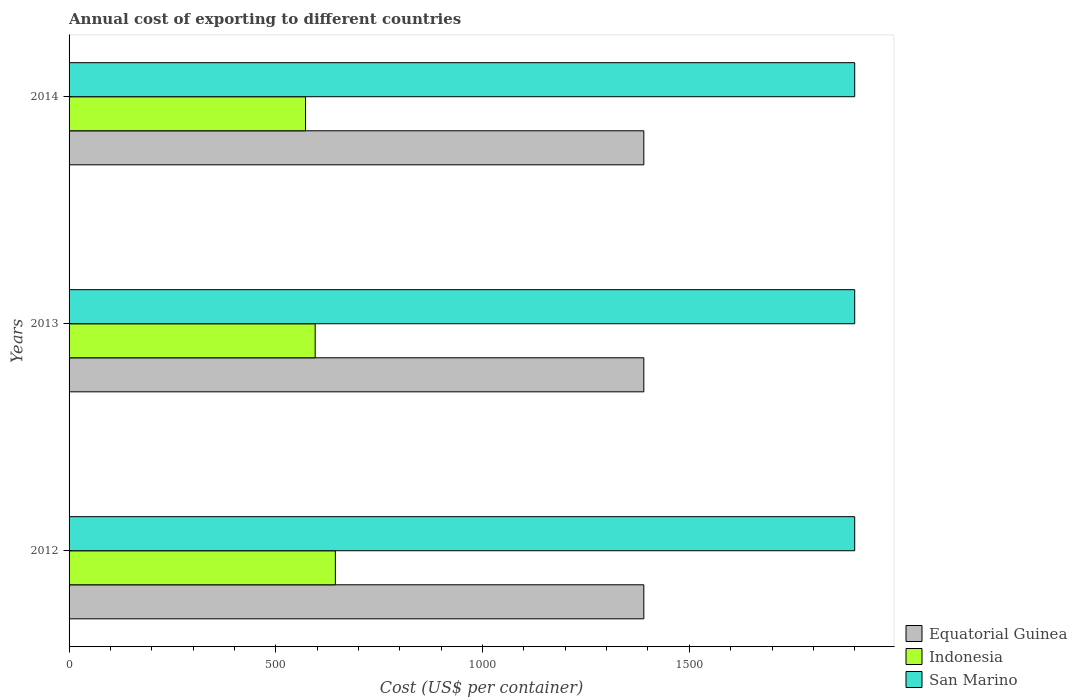What is the total annual cost of exporting in San Marino in 2013?
Your answer should be compact. 1900. Across all years, what is the maximum total annual cost of exporting in Indonesia?
Keep it short and to the point. 644. Across all years, what is the minimum total annual cost of exporting in Indonesia?
Provide a succinct answer. 571.8. In which year was the total annual cost of exporting in San Marino maximum?
Provide a short and direct response. 2012. What is the total total annual cost of exporting in Indonesia in the graph?
Keep it short and to the point. 1811. What is the difference between the total annual cost of exporting in Indonesia in 2012 and that in 2013?
Ensure brevity in your answer.  48.8. What is the difference between the total annual cost of exporting in Indonesia in 2014 and the total annual cost of exporting in San Marino in 2012?
Your response must be concise. -1328.2. What is the average total annual cost of exporting in Equatorial Guinea per year?
Your response must be concise. 1390. In the year 2012, what is the difference between the total annual cost of exporting in Equatorial Guinea and total annual cost of exporting in San Marino?
Provide a succinct answer. -510. In how many years, is the total annual cost of exporting in Indonesia greater than 1300 US$?
Your response must be concise. 0. What is the ratio of the total annual cost of exporting in San Marino in 2012 to that in 2013?
Provide a short and direct response. 1. What is the difference between the highest and the second highest total annual cost of exporting in Indonesia?
Keep it short and to the point. 48.8. What is the difference between the highest and the lowest total annual cost of exporting in San Marino?
Offer a very short reply. 0. In how many years, is the total annual cost of exporting in San Marino greater than the average total annual cost of exporting in San Marino taken over all years?
Offer a terse response. 0. Is the sum of the total annual cost of exporting in Indonesia in 2012 and 2014 greater than the maximum total annual cost of exporting in Equatorial Guinea across all years?
Offer a very short reply. No. What does the 3rd bar from the top in 2012 represents?
Keep it short and to the point. Equatorial Guinea. How many bars are there?
Your answer should be very brief. 9. Are all the bars in the graph horizontal?
Offer a very short reply. Yes. What is the difference between two consecutive major ticks on the X-axis?
Provide a short and direct response. 500. Are the values on the major ticks of X-axis written in scientific E-notation?
Make the answer very short. No. Does the graph contain any zero values?
Your answer should be very brief. No. Where does the legend appear in the graph?
Your answer should be very brief. Bottom right. How are the legend labels stacked?
Provide a succinct answer. Vertical. What is the title of the graph?
Ensure brevity in your answer.  Annual cost of exporting to different countries. Does "Estonia" appear as one of the legend labels in the graph?
Offer a terse response. No. What is the label or title of the X-axis?
Make the answer very short. Cost (US$ per container). What is the Cost (US$ per container) of Equatorial Guinea in 2012?
Ensure brevity in your answer.  1390. What is the Cost (US$ per container) in Indonesia in 2012?
Keep it short and to the point. 644. What is the Cost (US$ per container) of San Marino in 2012?
Your response must be concise. 1900. What is the Cost (US$ per container) of Equatorial Guinea in 2013?
Your response must be concise. 1390. What is the Cost (US$ per container) of Indonesia in 2013?
Provide a succinct answer. 595.2. What is the Cost (US$ per container) in San Marino in 2013?
Your answer should be very brief. 1900. What is the Cost (US$ per container) in Equatorial Guinea in 2014?
Ensure brevity in your answer.  1390. What is the Cost (US$ per container) of Indonesia in 2014?
Your response must be concise. 571.8. What is the Cost (US$ per container) in San Marino in 2014?
Provide a succinct answer. 1900. Across all years, what is the maximum Cost (US$ per container) in Equatorial Guinea?
Offer a very short reply. 1390. Across all years, what is the maximum Cost (US$ per container) in Indonesia?
Provide a succinct answer. 644. Across all years, what is the maximum Cost (US$ per container) in San Marino?
Offer a terse response. 1900. Across all years, what is the minimum Cost (US$ per container) of Equatorial Guinea?
Keep it short and to the point. 1390. Across all years, what is the minimum Cost (US$ per container) of Indonesia?
Make the answer very short. 571.8. Across all years, what is the minimum Cost (US$ per container) of San Marino?
Keep it short and to the point. 1900. What is the total Cost (US$ per container) in Equatorial Guinea in the graph?
Ensure brevity in your answer.  4170. What is the total Cost (US$ per container) of Indonesia in the graph?
Make the answer very short. 1811. What is the total Cost (US$ per container) in San Marino in the graph?
Ensure brevity in your answer.  5700. What is the difference between the Cost (US$ per container) in Equatorial Guinea in 2012 and that in 2013?
Offer a very short reply. 0. What is the difference between the Cost (US$ per container) of Indonesia in 2012 and that in 2013?
Offer a very short reply. 48.8. What is the difference between the Cost (US$ per container) of San Marino in 2012 and that in 2013?
Keep it short and to the point. 0. What is the difference between the Cost (US$ per container) in Equatorial Guinea in 2012 and that in 2014?
Give a very brief answer. 0. What is the difference between the Cost (US$ per container) in Indonesia in 2012 and that in 2014?
Ensure brevity in your answer.  72.2. What is the difference between the Cost (US$ per container) of Equatorial Guinea in 2013 and that in 2014?
Offer a very short reply. 0. What is the difference between the Cost (US$ per container) of Indonesia in 2013 and that in 2014?
Offer a very short reply. 23.4. What is the difference between the Cost (US$ per container) of San Marino in 2013 and that in 2014?
Make the answer very short. 0. What is the difference between the Cost (US$ per container) of Equatorial Guinea in 2012 and the Cost (US$ per container) of Indonesia in 2013?
Offer a terse response. 794.8. What is the difference between the Cost (US$ per container) in Equatorial Guinea in 2012 and the Cost (US$ per container) in San Marino in 2013?
Provide a short and direct response. -510. What is the difference between the Cost (US$ per container) of Indonesia in 2012 and the Cost (US$ per container) of San Marino in 2013?
Provide a short and direct response. -1256. What is the difference between the Cost (US$ per container) in Equatorial Guinea in 2012 and the Cost (US$ per container) in Indonesia in 2014?
Make the answer very short. 818.2. What is the difference between the Cost (US$ per container) in Equatorial Guinea in 2012 and the Cost (US$ per container) in San Marino in 2014?
Provide a short and direct response. -510. What is the difference between the Cost (US$ per container) of Indonesia in 2012 and the Cost (US$ per container) of San Marino in 2014?
Your response must be concise. -1256. What is the difference between the Cost (US$ per container) in Equatorial Guinea in 2013 and the Cost (US$ per container) in Indonesia in 2014?
Offer a terse response. 818.2. What is the difference between the Cost (US$ per container) of Equatorial Guinea in 2013 and the Cost (US$ per container) of San Marino in 2014?
Provide a short and direct response. -510. What is the difference between the Cost (US$ per container) of Indonesia in 2013 and the Cost (US$ per container) of San Marino in 2014?
Provide a succinct answer. -1304.8. What is the average Cost (US$ per container) of Equatorial Guinea per year?
Your answer should be very brief. 1390. What is the average Cost (US$ per container) of Indonesia per year?
Give a very brief answer. 603.67. What is the average Cost (US$ per container) of San Marino per year?
Offer a very short reply. 1900. In the year 2012, what is the difference between the Cost (US$ per container) of Equatorial Guinea and Cost (US$ per container) of Indonesia?
Your answer should be compact. 746. In the year 2012, what is the difference between the Cost (US$ per container) in Equatorial Guinea and Cost (US$ per container) in San Marino?
Your response must be concise. -510. In the year 2012, what is the difference between the Cost (US$ per container) of Indonesia and Cost (US$ per container) of San Marino?
Ensure brevity in your answer.  -1256. In the year 2013, what is the difference between the Cost (US$ per container) in Equatorial Guinea and Cost (US$ per container) in Indonesia?
Make the answer very short. 794.8. In the year 2013, what is the difference between the Cost (US$ per container) in Equatorial Guinea and Cost (US$ per container) in San Marino?
Your response must be concise. -510. In the year 2013, what is the difference between the Cost (US$ per container) of Indonesia and Cost (US$ per container) of San Marino?
Your answer should be very brief. -1304.8. In the year 2014, what is the difference between the Cost (US$ per container) of Equatorial Guinea and Cost (US$ per container) of Indonesia?
Offer a terse response. 818.2. In the year 2014, what is the difference between the Cost (US$ per container) of Equatorial Guinea and Cost (US$ per container) of San Marino?
Keep it short and to the point. -510. In the year 2014, what is the difference between the Cost (US$ per container) in Indonesia and Cost (US$ per container) in San Marino?
Offer a terse response. -1328.2. What is the ratio of the Cost (US$ per container) of Indonesia in 2012 to that in 2013?
Your response must be concise. 1.08. What is the ratio of the Cost (US$ per container) in San Marino in 2012 to that in 2013?
Provide a succinct answer. 1. What is the ratio of the Cost (US$ per container) in Equatorial Guinea in 2012 to that in 2014?
Ensure brevity in your answer.  1. What is the ratio of the Cost (US$ per container) in Indonesia in 2012 to that in 2014?
Provide a short and direct response. 1.13. What is the ratio of the Cost (US$ per container) of San Marino in 2012 to that in 2014?
Your answer should be compact. 1. What is the ratio of the Cost (US$ per container) of Equatorial Guinea in 2013 to that in 2014?
Make the answer very short. 1. What is the ratio of the Cost (US$ per container) in Indonesia in 2013 to that in 2014?
Keep it short and to the point. 1.04. What is the ratio of the Cost (US$ per container) of San Marino in 2013 to that in 2014?
Ensure brevity in your answer.  1. What is the difference between the highest and the second highest Cost (US$ per container) of Indonesia?
Provide a short and direct response. 48.8. What is the difference between the highest and the lowest Cost (US$ per container) of Equatorial Guinea?
Offer a terse response. 0. What is the difference between the highest and the lowest Cost (US$ per container) of Indonesia?
Your answer should be very brief. 72.2. 